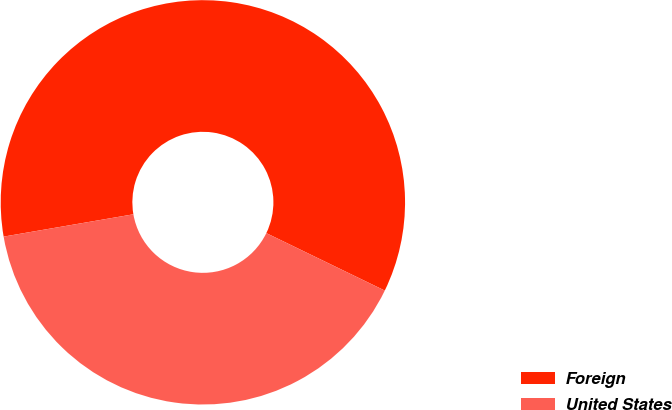<chart> <loc_0><loc_0><loc_500><loc_500><pie_chart><fcel>Foreign<fcel>United States<nl><fcel>59.9%<fcel>40.1%<nl></chart> 